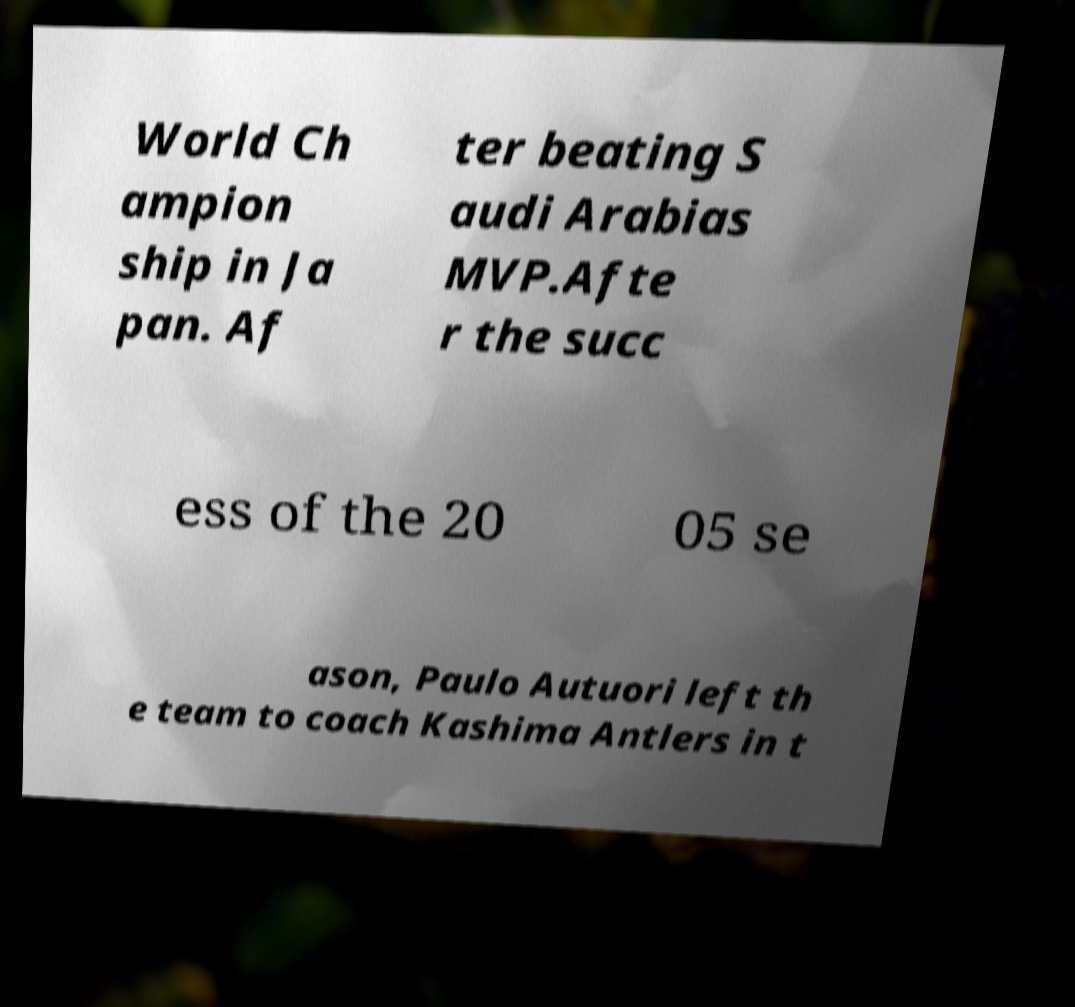For documentation purposes, I need the text within this image transcribed. Could you provide that? World Ch ampion ship in Ja pan. Af ter beating S audi Arabias MVP.Afte r the succ ess of the 20 05 se ason, Paulo Autuori left th e team to coach Kashima Antlers in t 